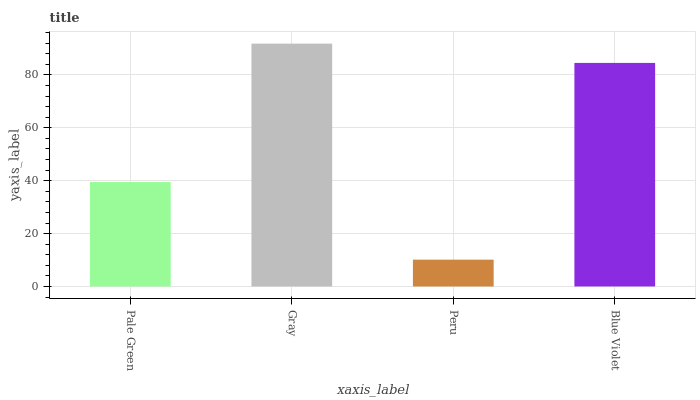Is Peru the minimum?
Answer yes or no. Yes. Is Gray the maximum?
Answer yes or no. Yes. Is Gray the minimum?
Answer yes or no. No. Is Peru the maximum?
Answer yes or no. No. Is Gray greater than Peru?
Answer yes or no. Yes. Is Peru less than Gray?
Answer yes or no. Yes. Is Peru greater than Gray?
Answer yes or no. No. Is Gray less than Peru?
Answer yes or no. No. Is Blue Violet the high median?
Answer yes or no. Yes. Is Pale Green the low median?
Answer yes or no. Yes. Is Pale Green the high median?
Answer yes or no. No. Is Gray the low median?
Answer yes or no. No. 